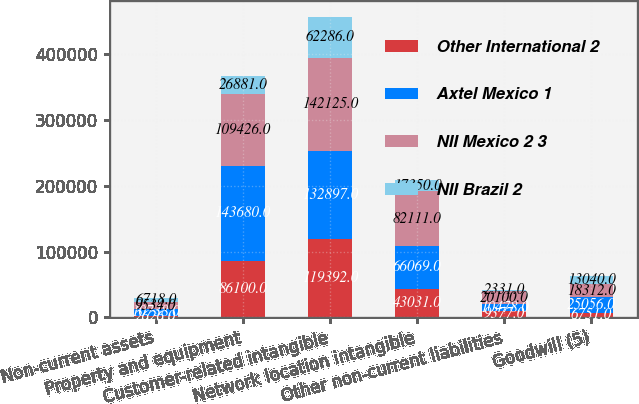Convert chart. <chart><loc_0><loc_0><loc_500><loc_500><stacked_bar_chart><ecel><fcel>Non-current assets<fcel>Property and equipment<fcel>Customer-related intangible<fcel>Network location intangible<fcel>Other non-current liabilities<fcel>Goodwill (5)<nl><fcel>Other International 2<fcel>2626<fcel>86100<fcel>119392<fcel>43031<fcel>9377<fcel>6751<nl><fcel>Axtel Mexico 1<fcel>10738<fcel>143680<fcel>132897<fcel>66069<fcel>10478<fcel>25056<nl><fcel>NII Mexico 2 3<fcel>9534<fcel>109426<fcel>142125<fcel>82111<fcel>20100<fcel>18312<nl><fcel>NII Brazil 2<fcel>6718<fcel>26881<fcel>62286<fcel>17350<fcel>2331<fcel>13040<nl></chart> 